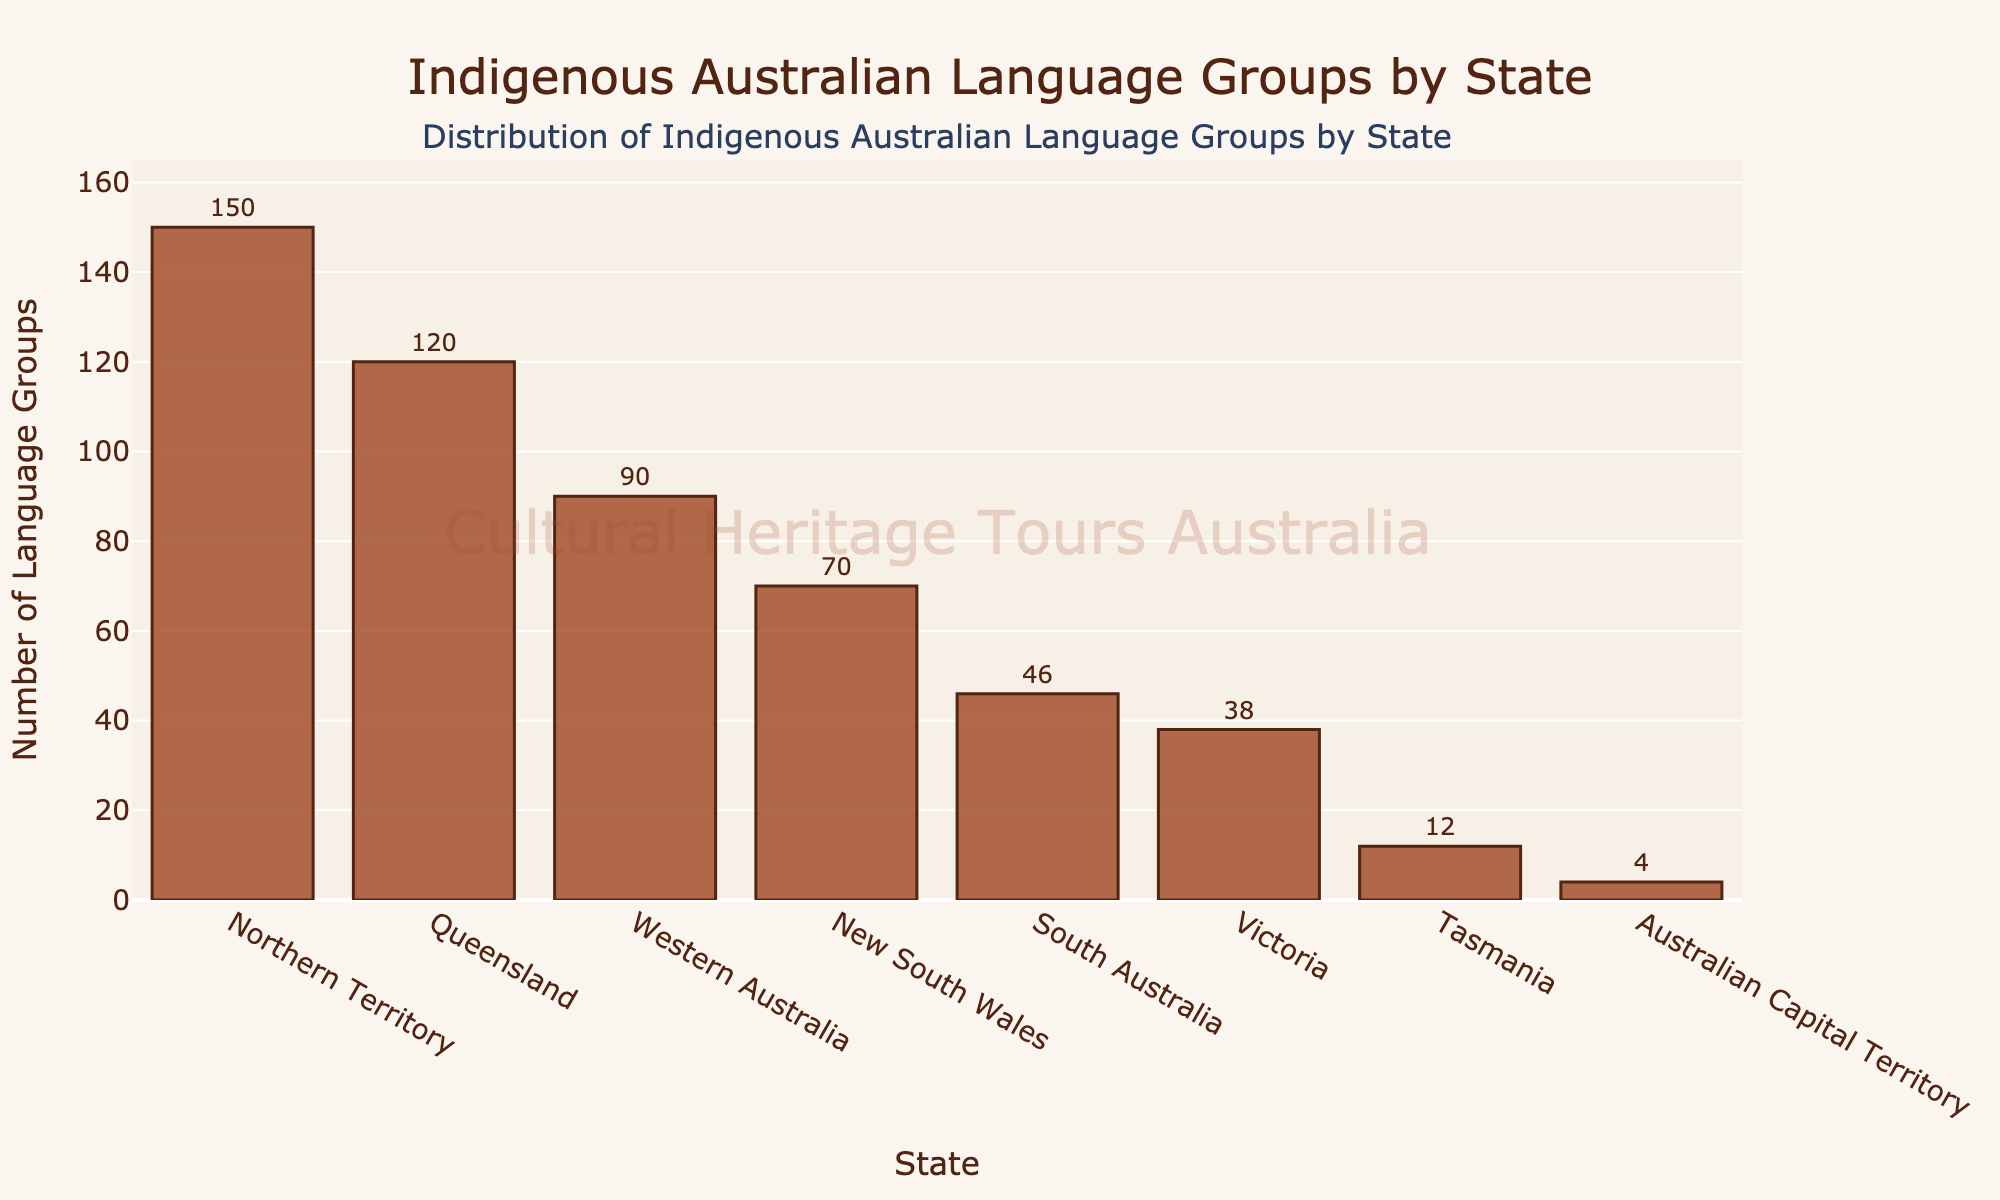Which state has the highest number of Indigenous Australian language groups? By looking at the heights of the bars, the state with the highest bar represents Northern Territory.
Answer: Northern Territory Which two states have the closest numbers of Indigenous Australian language groups? By comparing the heights of the bars visually, Victoria and South Australia have relatively close numbers.
Answer: Victoria and South Australia What is the difference in the number of language groups between Queensland and Western Australia? By looking at the bar lengths, Queensland has 120 language groups and Western Australia has 90. So, the difference is 120 - 90.
Answer: 30 Which state has more Indigenous Australian language groups: New South Wales or Western Australia? By comparing the heights of their bars, Western Australia has a higher bar than New South Wales.
Answer: Western Australia How many more Indigenous Australian language groups does the Northern Territory have than Tasmania? The Northern Territory has 150 language groups, while Tasmania has 12. So, the difference is 150 - 12.
Answer: 138 What is the total number of Indigenous Australian language groups in all states combined? Summing up the values: 70 + 120 + 150 + 90 + 46 + 38 + 12 + 4 = 530.
Answer: 530 Which state has the smallest number of Indigenous Australian language groups? By looking at the bar heights and identifying the shortest bar, the Australian Capital Territory has the smallest number with 4 groups.
Answer: Australian Capital Territory How many Indigenous Australian language groups are there in Victoria compared to South Australia? Victoria has 38 language groups and South Australia has 46. By comparing, South Australia has 46 - 38 = 8 more groups.
Answer: 8 What is the average number of Indigenous Australian language groups across all states? By calculating the total number of language groups (530) and dividing by the number of states (8), the average is 530 / 8 = 66.25.
Answer: 66.25 If you combine the number of language groups in New South Wales, Queensland, and Northern Territory, how many are there in total? Summing the values for New South Wales (70), Queensland (120), and Northern Territory (150): 70 + 120 + 150 = 340.
Answer: 340 